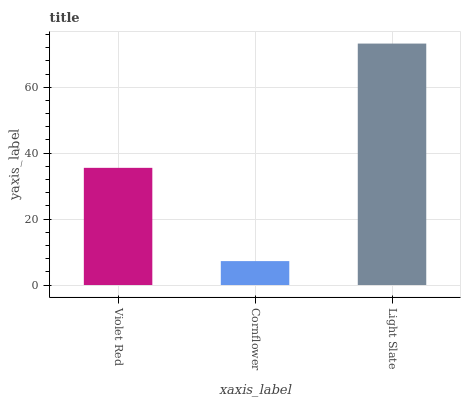Is Light Slate the minimum?
Answer yes or no. No. Is Cornflower the maximum?
Answer yes or no. No. Is Light Slate greater than Cornflower?
Answer yes or no. Yes. Is Cornflower less than Light Slate?
Answer yes or no. Yes. Is Cornflower greater than Light Slate?
Answer yes or no. No. Is Light Slate less than Cornflower?
Answer yes or no. No. Is Violet Red the high median?
Answer yes or no. Yes. Is Violet Red the low median?
Answer yes or no. Yes. Is Cornflower the high median?
Answer yes or no. No. Is Cornflower the low median?
Answer yes or no. No. 